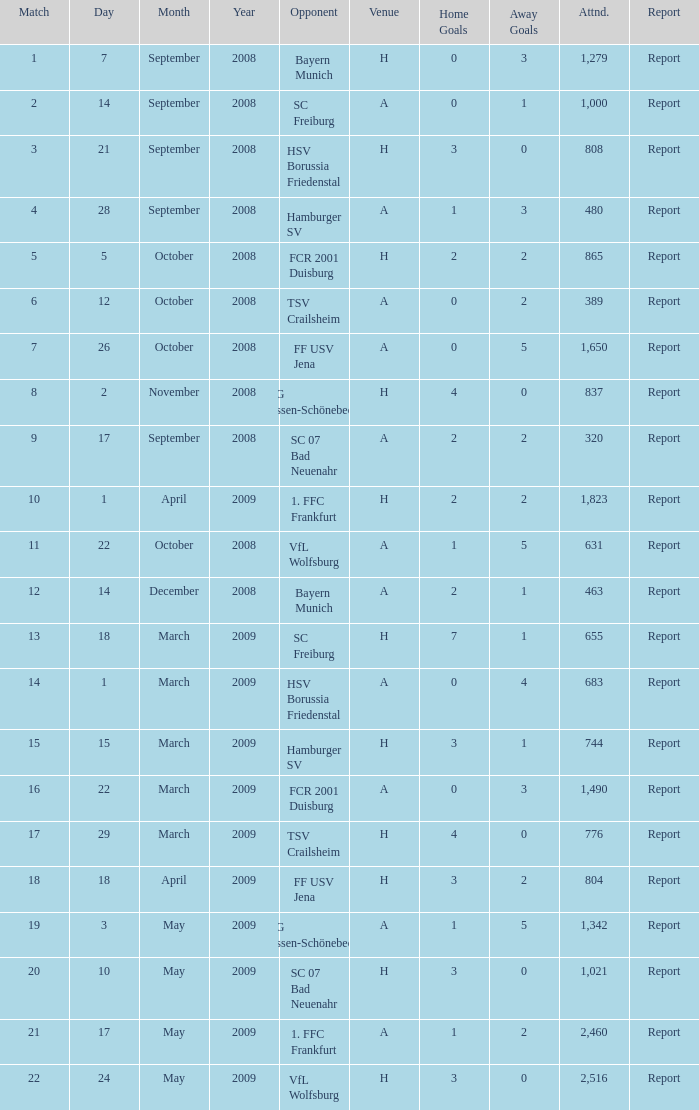Which match did FCR 2001 Duisburg participate as the opponent? 21.0. Parse the table in full. {'header': ['Match', 'Day', 'Month', 'Year', 'Opponent', 'Venue', 'Home Goals', 'Away Goals', 'Attnd.', 'Report'], 'rows': [['1', '7', 'September', '2008', 'Bayern Munich', 'H', '0', '3', '1,279', 'Report'], ['2', '14', 'September', '2008', 'SC Freiburg', 'A', '0', '1', '1,000', 'Report'], ['3', '21', 'September', '2008', 'HSV Borussia Friedenstal', 'H', '3', '0', '808', 'Report'], ['4', '28', 'September', '2008', 'Hamburger SV', 'A', '1', '3', '480', 'Report'], ['5', '5', 'October', '2008', 'FCR 2001 Duisburg', 'H', '2', '2', '865', 'Report'], ['6', '12', 'October', '2008', 'TSV Crailsheim', 'A', '0', '2', '389', 'Report'], ['7', '26', 'October', '2008', 'FF USV Jena', 'A', '0', '5', '1,650', 'Report'], ['8', '2', 'November', '2008', 'SG Essen-Schönebeck', 'H', '4', '0', '837', 'Report'], ['9', '17', 'September', '2008', 'SC 07 Bad Neuenahr', 'A', '2', '2', '320', 'Report'], ['10', '1', 'April', '2009', '1. FFC Frankfurt', 'H', '2', '2', '1,823', 'Report'], ['11', '22', 'October', '2008', 'VfL Wolfsburg', 'A', '1', '5', '631', 'Report'], ['12', '14', 'December', '2008', 'Bayern Munich', 'A', '2', '1', '463', 'Report'], ['13', '18', 'March', '2009', 'SC Freiburg', 'H', '7', '1', '655', 'Report'], ['14', '1', 'March', '2009', 'HSV Borussia Friedenstal', 'A', '0', '4', '683', 'Report'], ['15', '15', 'March', '2009', 'Hamburger SV', 'H', '3', '1', '744', 'Report'], ['16', '22', 'March', '2009', 'FCR 2001 Duisburg', 'A', '0', '3', '1,490', 'Report'], ['17', '29', 'March', '2009', 'TSV Crailsheim', 'H', '4', '0', '776', 'Report'], ['18', '18', 'April', '2009', 'FF USV Jena', 'H', '3', '2', '804', 'Report'], ['19', '3', 'May', '2009', 'SG Essen-Schönebeck', 'A', '1', '5', '1,342', 'Report'], ['20', '10', 'May', '2009', 'SC 07 Bad Neuenahr', 'H', '3', '0', '1,021', 'Report'], ['21', '17', 'May', '2009', '1. FFC Frankfurt', 'A', '1', '2', '2,460', 'Report'], ['22', '24', 'May', '2009', 'VfL Wolfsburg', 'H', '3', '0', '2,516', 'Report']]} 